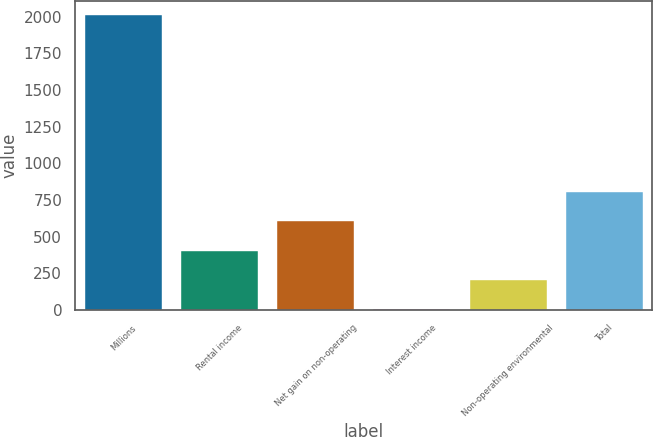Convert chart to OTSL. <chart><loc_0><loc_0><loc_500><loc_500><bar_chart><fcel>Millions<fcel>Rental income<fcel>Net gain on non-operating<fcel>Interest income<fcel>Non-operating environmental<fcel>Total<nl><fcel>2009<fcel>405.8<fcel>606.2<fcel>5<fcel>205.4<fcel>806.6<nl></chart> 